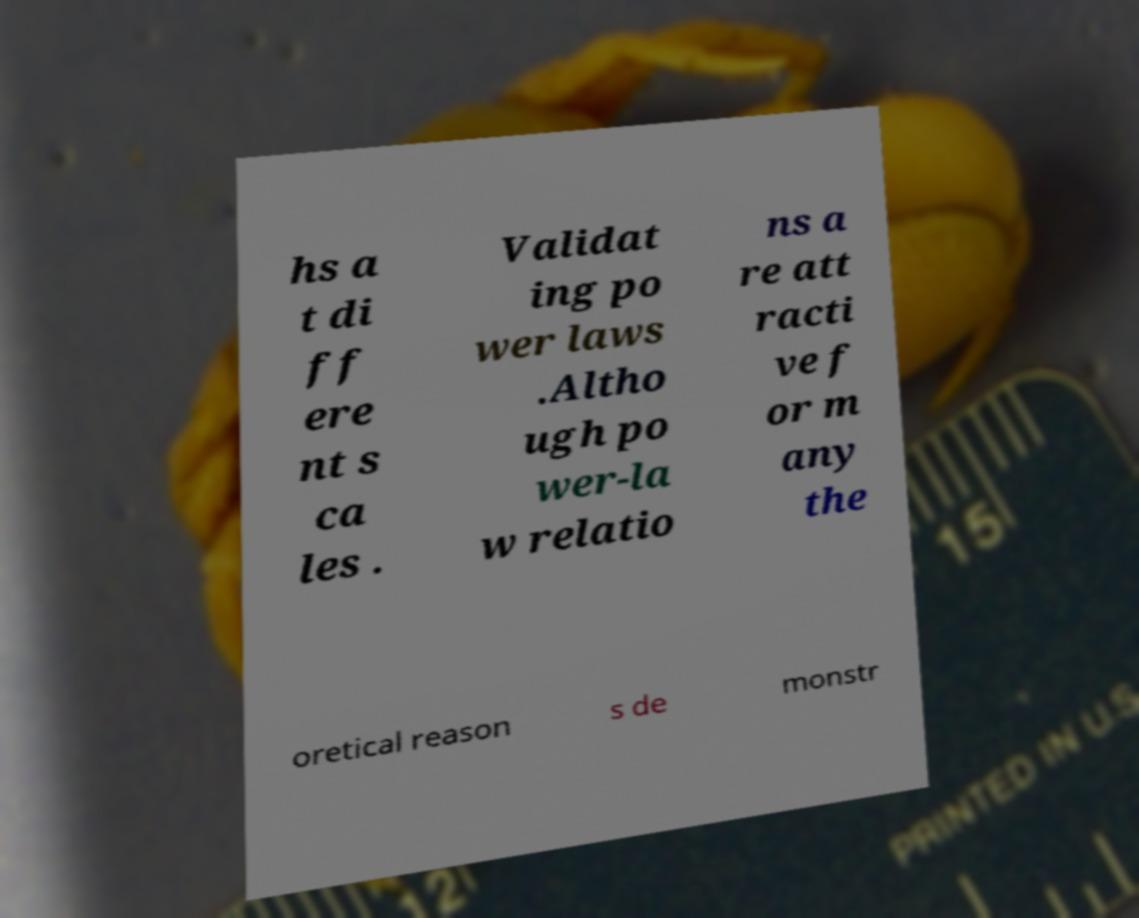For documentation purposes, I need the text within this image transcribed. Could you provide that? hs a t di ff ere nt s ca les . Validat ing po wer laws .Altho ugh po wer-la w relatio ns a re att racti ve f or m any the oretical reason s de monstr 